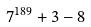Convert formula to latex. <formula><loc_0><loc_0><loc_500><loc_500>7 ^ { 1 8 9 } + 3 - 8</formula> 